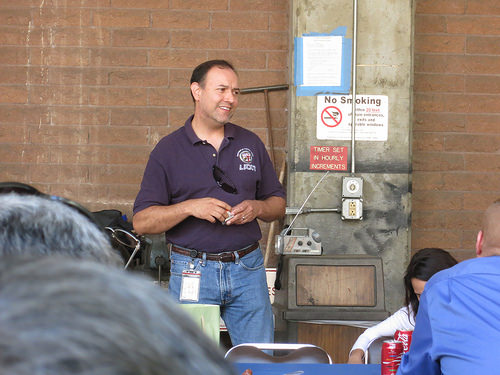<image>
Can you confirm if the radio is on the man? No. The radio is not positioned on the man. They may be near each other, but the radio is not supported by or resting on top of the man. Is there a sign to the left of the man? Yes. From this viewpoint, the sign is positioned to the left side relative to the man. Where is the man in relation to the garbage can? Is it to the right of the garbage can? No. The man is not to the right of the garbage can. The horizontal positioning shows a different relationship. 